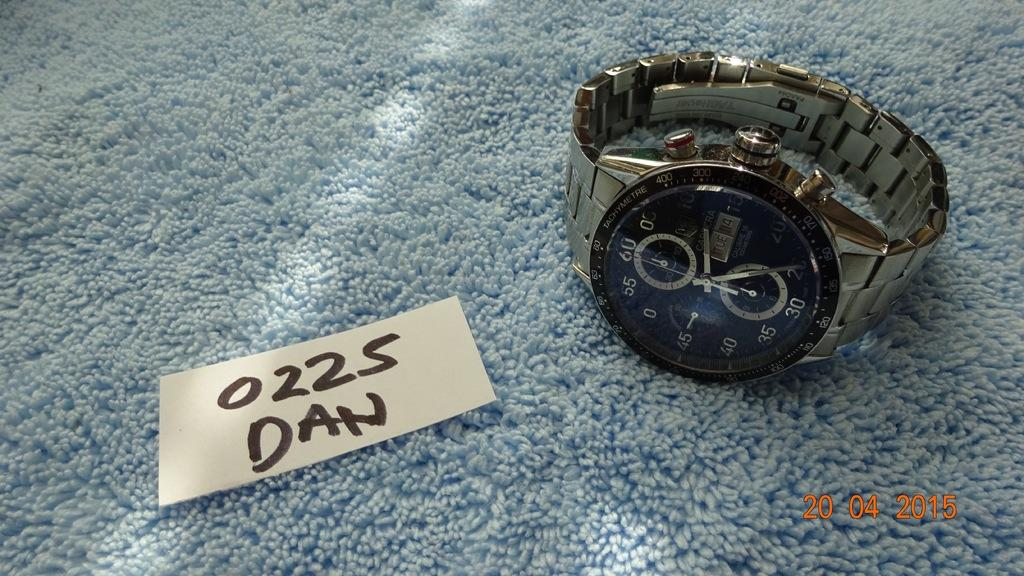<image>
Create a compact narrative representing the image presented. A silver banded wrist watch with a piece of paper that says 0225 Dan next to it. 